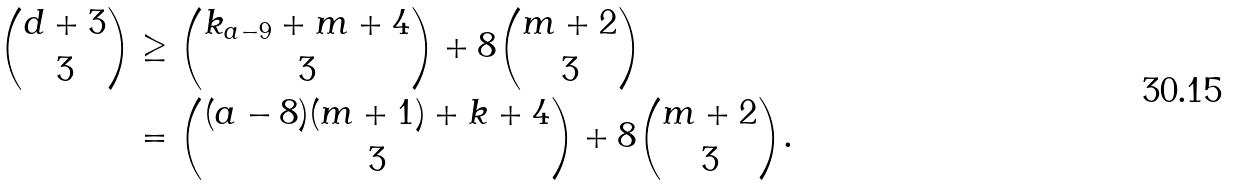<formula> <loc_0><loc_0><loc_500><loc_500>\binom { d + 3 } { 3 } & \geq \binom { k _ { a - 9 } + m + 4 } { 3 } + 8 \binom { m + 2 } { 3 } \\ & = \binom { ( a - 8 ) ( m + 1 ) + k + 4 } { 3 } + 8 \binom { m + 2 } { 3 } .</formula> 